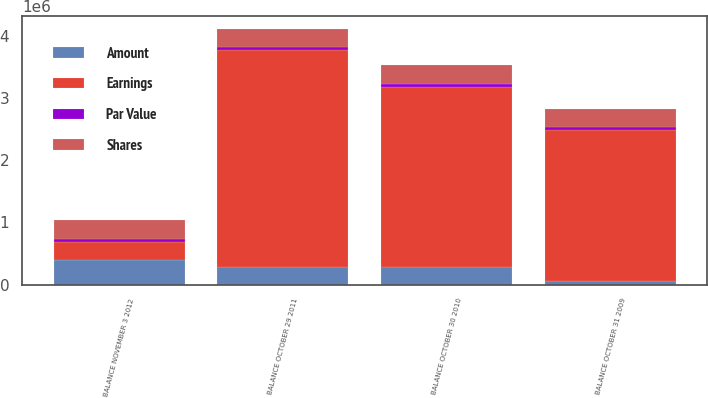Convert chart. <chart><loc_0><loc_0><loc_500><loc_500><stacked_bar_chart><ecel><fcel>BALANCE OCTOBER 31 2009<fcel>BALANCE OCTOBER 30 2010<fcel>BALANCE OCTOBER 29 2011<fcel>BALANCE NOVEMBER 3 2012<nl><fcel>Shares<fcel>291862<fcel>298653<fcel>297961<fcel>301389<nl><fcel>Par Value<fcel>48645<fcel>49777<fcel>49661<fcel>50233<nl><fcel>Amount<fcel>56306<fcel>286969<fcel>289587<fcel>390651<nl><fcel>Earnings<fcel>2.43445e+06<fcel>2.89657e+06<fcel>3.48233e+06<fcel>291862<nl></chart> 